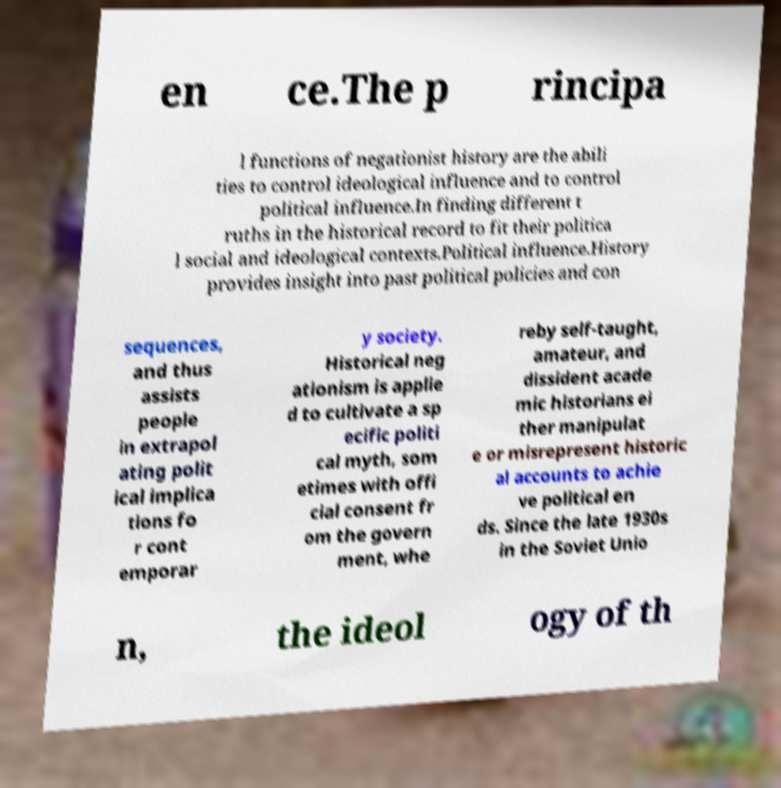For documentation purposes, I need the text within this image transcribed. Could you provide that? en ce.The p rincipa l functions of negationist history are the abili ties to control ideological influence and to control political influence.In finding different t ruths in the historical record to fit their politica l social and ideological contexts.Political influence.History provides insight into past political policies and con sequences, and thus assists people in extrapol ating polit ical implica tions fo r cont emporar y society. Historical neg ationism is applie d to cultivate a sp ecific politi cal myth, som etimes with offi cial consent fr om the govern ment, whe reby self-taught, amateur, and dissident acade mic historians ei ther manipulat e or misrepresent historic al accounts to achie ve political en ds. Since the late 1930s in the Soviet Unio n, the ideol ogy of th 